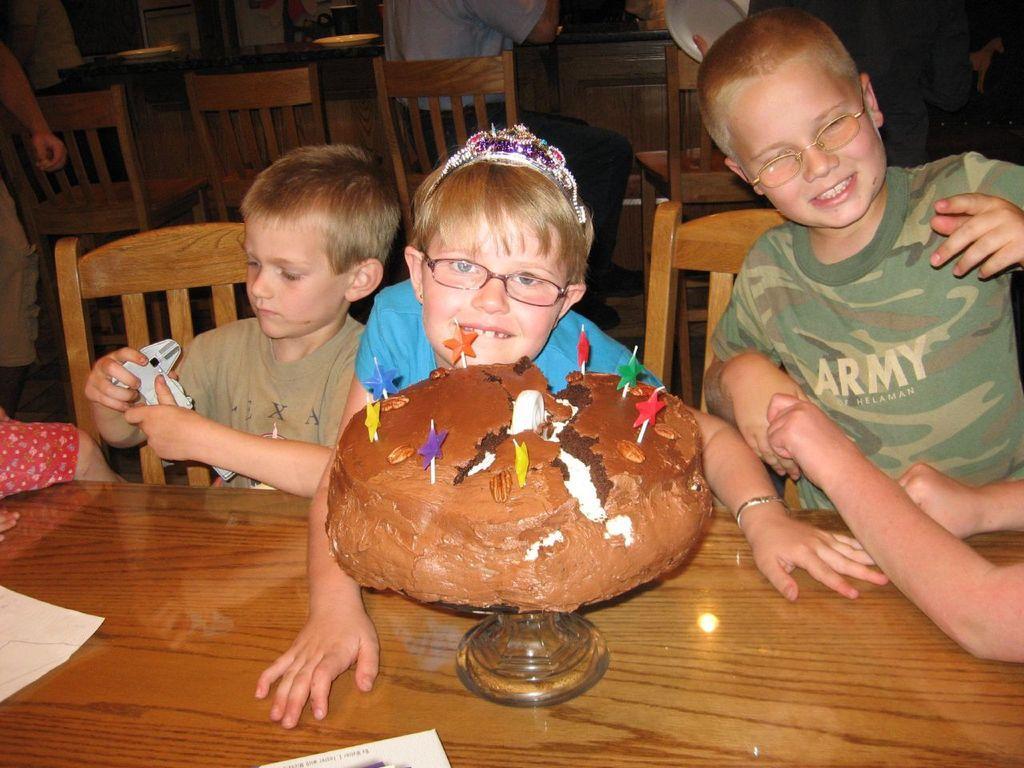Describe this image in one or two sentences. In this picture we can see three children are in the middle. This is the cake on the table. And on the background we can see some chairs. 